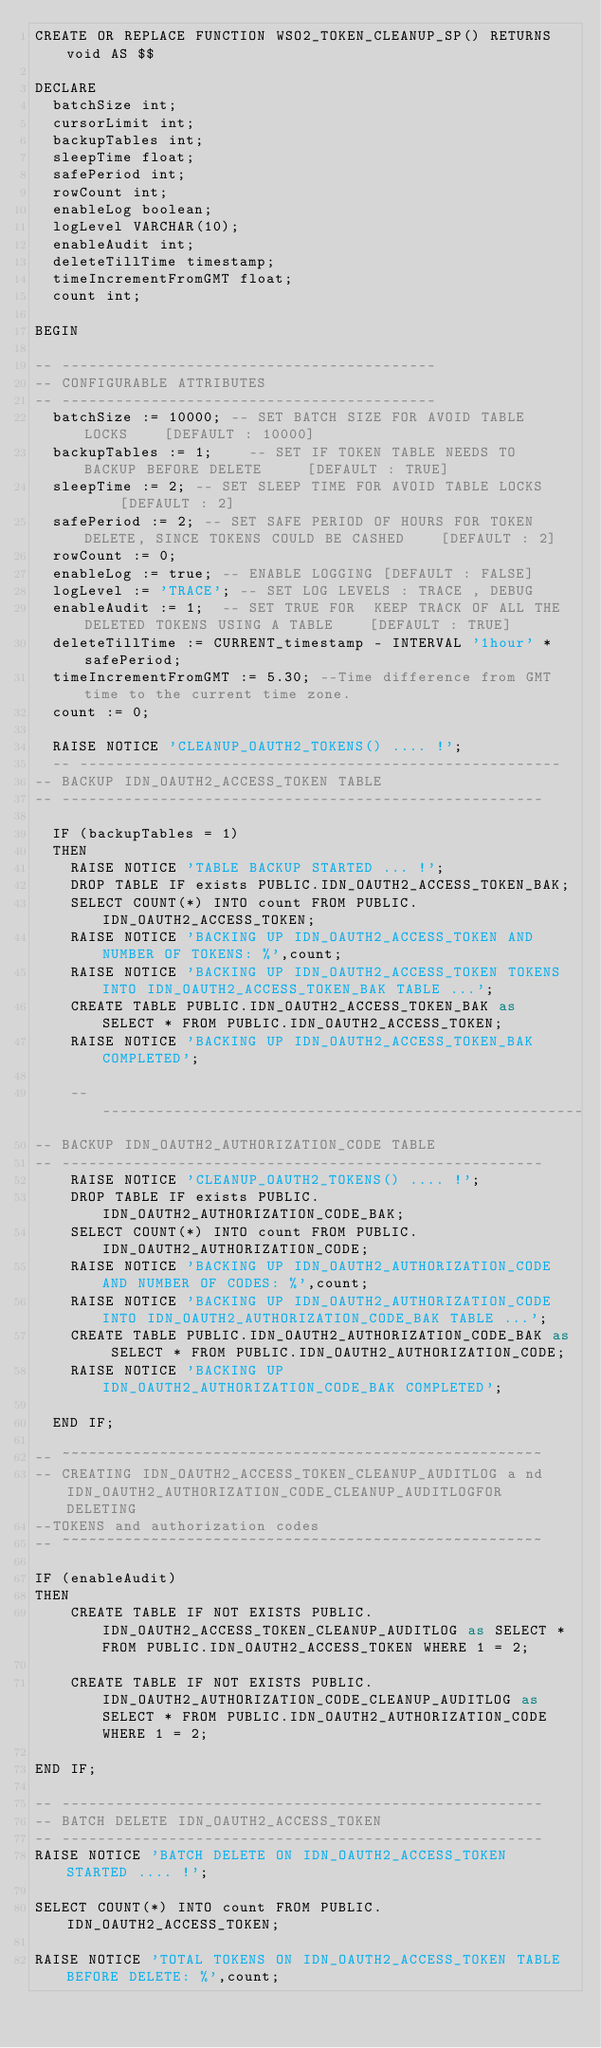Convert code to text. <code><loc_0><loc_0><loc_500><loc_500><_SQL_>CREATE OR REPLACE FUNCTION WSO2_TOKEN_CLEANUP_SP() RETURNS void AS $$

DECLARE
  batchSize int;
  cursorLimit int;
  backupTables int;
  sleepTime float;
  safePeriod int;
  rowCount int;
  enableLog boolean;
  logLevel VARCHAR(10);
  enableAudit int;
  deleteTillTime timestamp;
  timeIncrementFromGMT float;
  count int;

BEGIN

-- ------------------------------------------
-- CONFIGURABLE ATTRIBUTES
-- ------------------------------------------
  batchSize := 10000; -- SET BATCH SIZE FOR AVOID TABLE LOCKS    [DEFAULT : 10000]
  backupTables := 1;    -- SET IF TOKEN TABLE NEEDS TO BACKUP BEFORE DELETE     [DEFAULT : TRUE]
  sleepTime := 2; -- SET SLEEP TIME FOR AVOID TABLE LOCKS     [DEFAULT : 2]
  safePeriod := 2; -- SET SAFE PERIOD OF HOURS FOR TOKEN DELETE, SINCE TOKENS COULD BE CASHED    [DEFAULT : 2]
  rowCount := 0;
  enableLog := true; -- ENABLE LOGGING [DEFAULT : FALSE]
  logLevel := 'TRACE'; -- SET LOG LEVELS : TRACE , DEBUG
  enableAudit := 1;  -- SET TRUE FOR  KEEP TRACK OF ALL THE DELETED TOKENS USING A TABLE    [DEFAULT : TRUE]
  deleteTillTime := CURRENT_timestamp - INTERVAL '1hour' * safePeriod;
  timeIncrementFromGMT := 5.30; --Time difference from GMT time to the current time zone.
  count := 0;

  RAISE NOTICE 'CLEANUP_OAUTH2_TOKENS() .... !';
  -- ------------------------------------------------------
-- BACKUP IDN_OAUTH2_ACCESS_TOKEN TABLE
-- ------------------------------------------------------

  IF (backupTables = 1)
  THEN
    RAISE NOTICE 'TABLE BACKUP STARTED ... !';
    DROP TABLE IF exists PUBLIC.IDN_OAUTH2_ACCESS_TOKEN_BAK;
    SELECT COUNT(*) INTO count FROM PUBLIC.IDN_OAUTH2_ACCESS_TOKEN;
    RAISE NOTICE 'BACKING UP IDN_OAUTH2_ACCESS_TOKEN AND NUMBER OF TOKENS: %',count;
    RAISE NOTICE 'BACKING UP IDN_OAUTH2_ACCESS_TOKEN TOKENS INTO IDN_OAUTH2_ACCESS_TOKEN_BAK TABLE ...';
    CREATE TABLE PUBLIC.IDN_OAUTH2_ACCESS_TOKEN_BAK as SELECT * FROM PUBLIC.IDN_OAUTH2_ACCESS_TOKEN;
    RAISE NOTICE 'BACKING UP IDN_OAUTH2_ACCESS_TOKEN_BAK COMPLETED';

    -- ------------------------------------------------------
-- BACKUP IDN_OAUTH2_AUTHORIZATION_CODE TABLE
-- ------------------------------------------------------
	RAISE NOTICE 'CLEANUP_OAUTH2_TOKENS() .... !';
  	DROP TABLE IF exists PUBLIC.IDN_OAUTH2_AUTHORIZATION_CODE_BAK;
    SELECT COUNT(*) INTO count FROM PUBLIC.IDN_OAUTH2_AUTHORIZATION_CODE;
	RAISE NOTICE 'BACKING UP IDN_OAUTH2_AUTHORIZATION_CODE AND NUMBER OF CODES: %',count;
	RAISE NOTICE 'BACKING UP IDN_OAUTH2_AUTHORIZATION_CODE INTO IDN_OAUTH2_AUTHORIZATION_CODE_BAK TABLE ...';
    CREATE TABLE PUBLIC.IDN_OAUTH2_AUTHORIZATION_CODE_BAK as SELECT * FROM PUBLIC.IDN_OAUTH2_AUTHORIZATION_CODE;
    RAISE NOTICE 'BACKING UP IDN_OAUTH2_AUTHORIZATION_CODE_BAK COMPLETED';

  END IF;

-- ~~~~~~~~~~~~~~~~~~~~~~~~~~~~~~~~~~~~~~~~~~~~~~~~~~~~~~
-- CREATING IDN_OAUTH2_ACCESS_TOKEN_CLEANUP_AUDITLOG a nd IDN_OAUTH2_AUTHORIZATION_CODE_CLEANUP_AUDITLOGFOR DELETING
--TOKENS and authorization codes
-- ~~~~~~~~~~~~~~~~~~~~~~~~~~~~~~~~~~~~~~~~~~~~~~~~~~~~~~

IF (enableAudit)
THEN
    CREATE TABLE IF NOT EXISTS PUBLIC.IDN_OAUTH2_ACCESS_TOKEN_CLEANUP_AUDITLOG as SELECT * FROM PUBLIC.IDN_OAUTH2_ACCESS_TOKEN WHERE 1 = 2;

    CREATE TABLE IF NOT EXISTS PUBLIC.IDN_OAUTH2_AUTHORIZATION_CODE_CLEANUP_AUDITLOG as SELECT * FROM PUBLIC.IDN_OAUTH2_AUTHORIZATION_CODE WHERE 1 = 2;

END IF;

-- ------------------------------------------------------
-- BATCH DELETE IDN_OAUTH2_ACCESS_TOKEN
-- ------------------------------------------------------
RAISE NOTICE 'BATCH DELETE ON IDN_OAUTH2_ACCESS_TOKEN STARTED .... !';

SELECT COUNT(*) INTO count FROM PUBLIC.IDN_OAUTH2_ACCESS_TOKEN;

RAISE NOTICE 'TOTAL TOKENS ON IDN_OAUTH2_ACCESS_TOKEN TABLE BEFORE DELETE: %',count;
</code> 